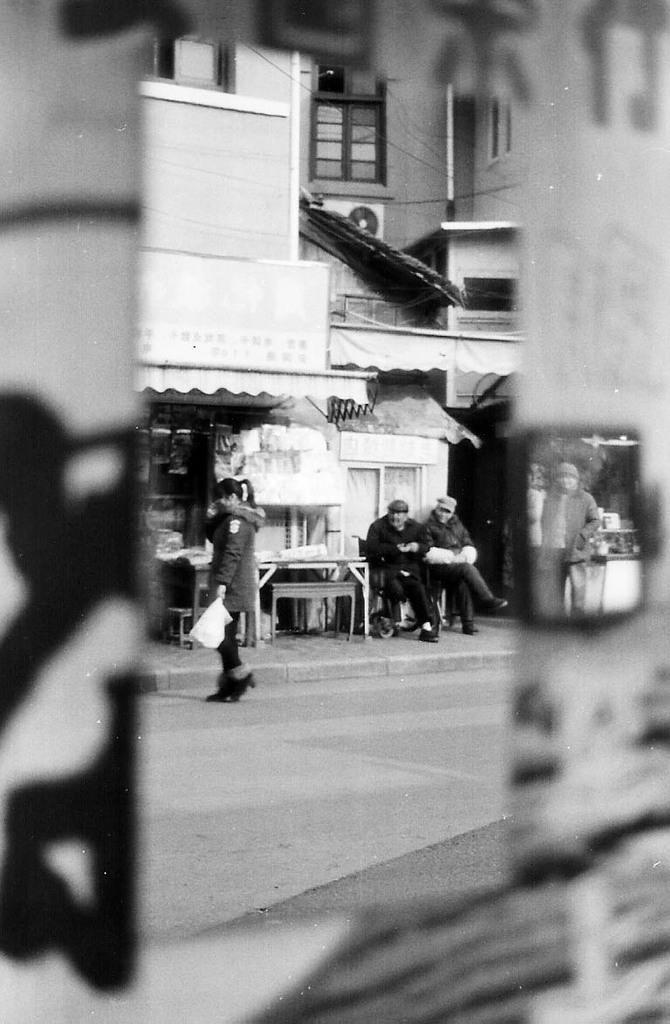Describe this image in one or two sentences. In this image I can see the black and white picture in which I can see the road, a person standing on the road, the side walk, few persons sitting on benches on the sidewalk and few buildings in the background. 